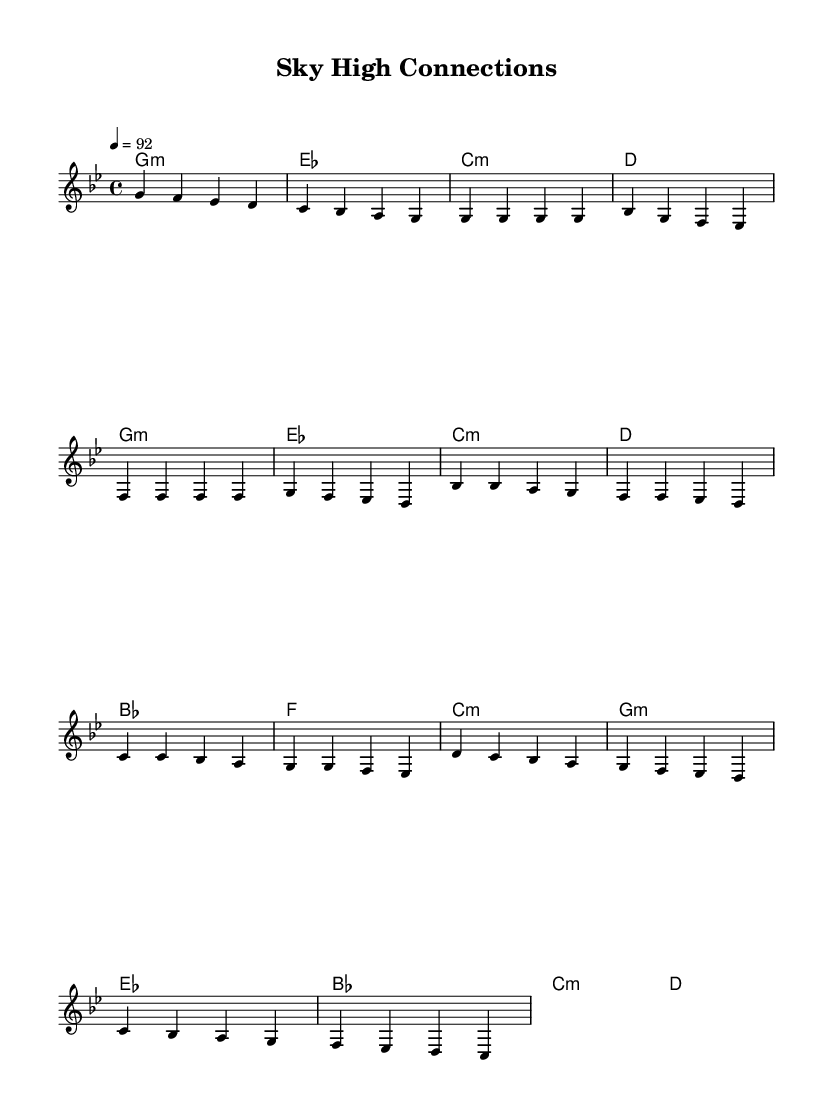What is the key signature of this music? The piece is in G minor, which is indicated by the "g" symbol after the \key command. It usually contains two flats in the key signature, which are not explicitly shown but implied by the key.
Answer: G minor What is the time signature of this music? The time signature is indicated by the \time command and is noted as 4/4. This means there are four beats in each measure and a quarter note receives one beat.
Answer: 4/4 What is the tempo marking for this music? The tempo is indicated by the \tempo command, set at 92 beats per minute. This gives a moderate pace for the piece.
Answer: 92 What is the structure of the piece? The piece has a clear structure with defined sections: Intro, Verse, Chorus, and Bridge. Each section can be identified by the patterns and repetitions in the melody and harmonies.
Answer: Intro, Verse, Chorus, Bridge How many measures are there in the Chorus? By counting the measures in the Chorus section, which is clearly labeled in the melody, there are four measures in the Chorus.
Answer: 4 What type of music is represented by this sheet? The style is characterized by rhythmic speech patterns and storytelling, typical of rap music. Furthermore, the title "Sky High Connections" indicates thematic content related to diverse encounters.
Answer: Rap 